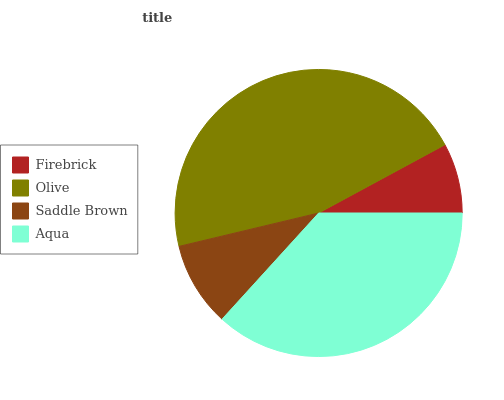Is Firebrick the minimum?
Answer yes or no. Yes. Is Olive the maximum?
Answer yes or no. Yes. Is Saddle Brown the minimum?
Answer yes or no. No. Is Saddle Brown the maximum?
Answer yes or no. No. Is Olive greater than Saddle Brown?
Answer yes or no. Yes. Is Saddle Brown less than Olive?
Answer yes or no. Yes. Is Saddle Brown greater than Olive?
Answer yes or no. No. Is Olive less than Saddle Brown?
Answer yes or no. No. Is Aqua the high median?
Answer yes or no. Yes. Is Saddle Brown the low median?
Answer yes or no. Yes. Is Olive the high median?
Answer yes or no. No. Is Firebrick the low median?
Answer yes or no. No. 